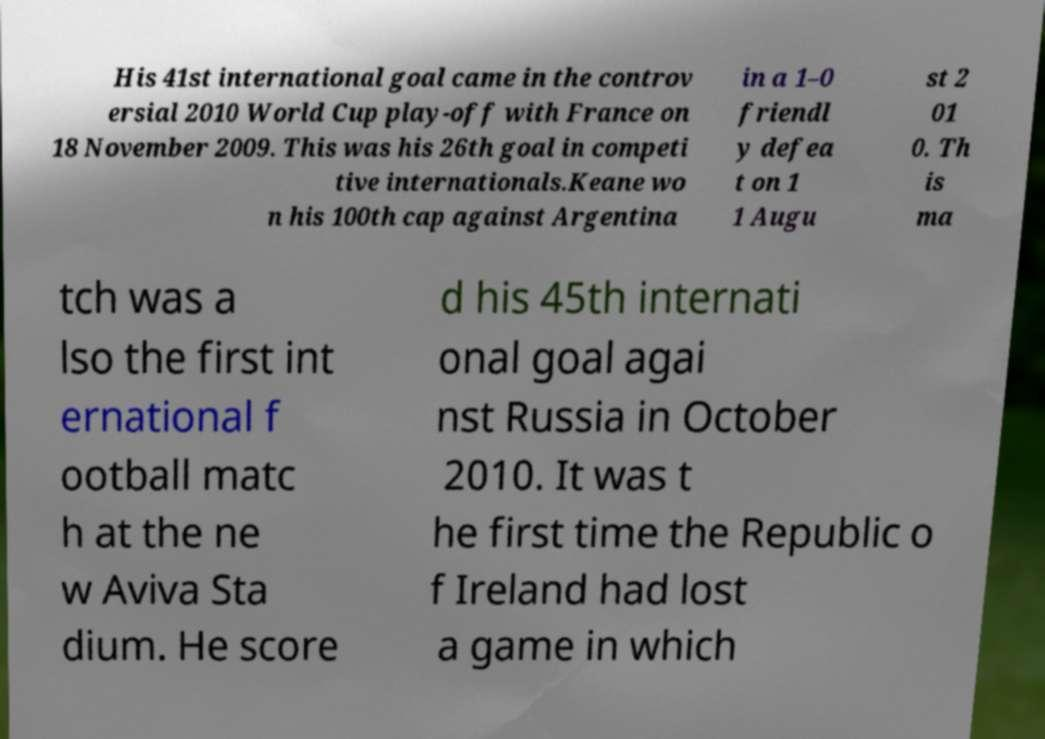Please identify and transcribe the text found in this image. His 41st international goal came in the controv ersial 2010 World Cup play-off with France on 18 November 2009. This was his 26th goal in competi tive internationals.Keane wo n his 100th cap against Argentina in a 1–0 friendl y defea t on 1 1 Augu st 2 01 0. Th is ma tch was a lso the first int ernational f ootball matc h at the ne w Aviva Sta dium. He score d his 45th internati onal goal agai nst Russia in October 2010. It was t he first time the Republic o f Ireland had lost a game in which 